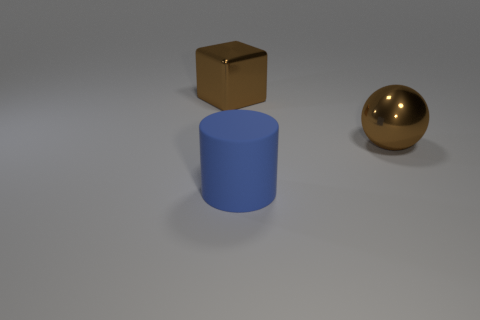Add 2 small gray metal spheres. How many objects exist? 5 Subtract all balls. How many objects are left? 2 Add 1 brown metallic things. How many brown metallic things are left? 3 Add 1 large blue cylinders. How many large blue cylinders exist? 2 Subtract 0 green cylinders. How many objects are left? 3 Subtract all big blue shiny blocks. Subtract all brown balls. How many objects are left? 2 